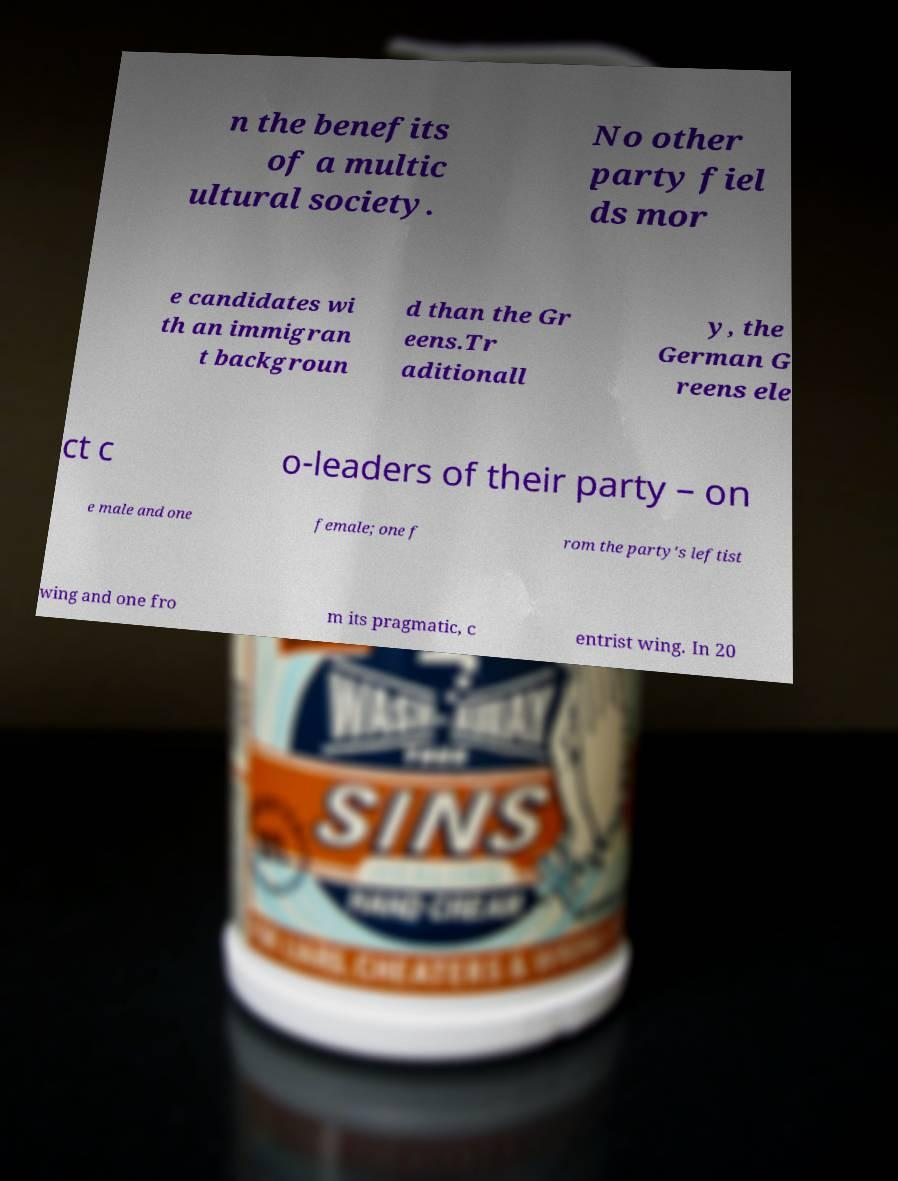Could you assist in decoding the text presented in this image and type it out clearly? n the benefits of a multic ultural society. No other party fiel ds mor e candidates wi th an immigran t backgroun d than the Gr eens.Tr aditionall y, the German G reens ele ct c o-leaders of their party – on e male and one female; one f rom the party's leftist wing and one fro m its pragmatic, c entrist wing. In 20 